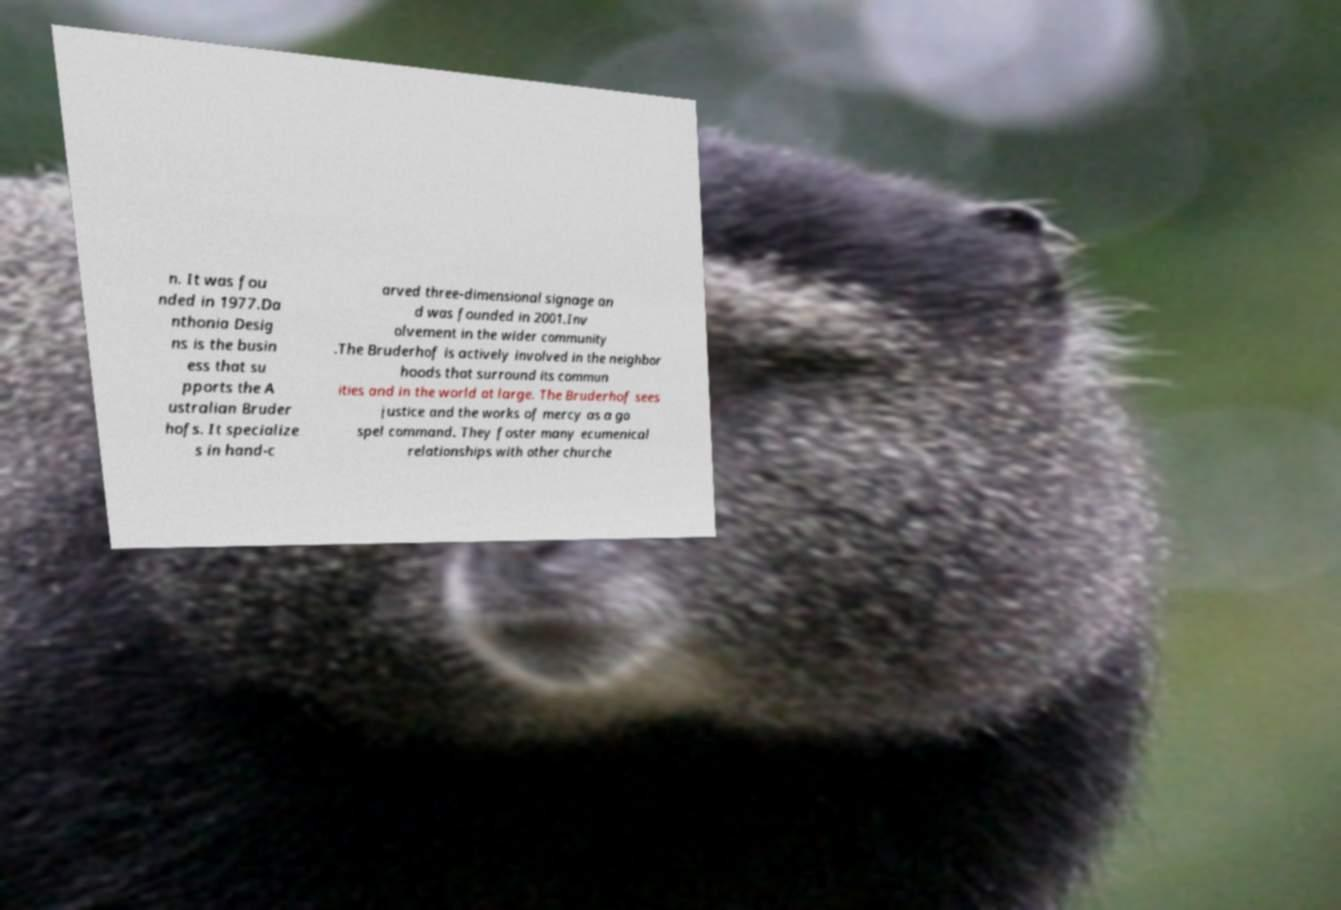Can you accurately transcribe the text from the provided image for me? n. It was fou nded in 1977.Da nthonia Desig ns is the busin ess that su pports the A ustralian Bruder hofs. It specialize s in hand-c arved three-dimensional signage an d was founded in 2001.Inv olvement in the wider community .The Bruderhof is actively involved in the neighbor hoods that surround its commun ities and in the world at large. The Bruderhof sees justice and the works of mercy as a go spel command. They foster many ecumenical relationships with other churche 